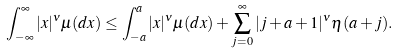<formula> <loc_0><loc_0><loc_500><loc_500>\int _ { - \infty } ^ { \infty } | x | ^ { \nu } \mu ( d x ) \leq \int _ { - a } ^ { a } | x | ^ { \nu } \mu ( d x ) + \sum _ { j = 0 } ^ { \infty } | j + a + 1 | ^ { \nu } \eta ( a + j ) .</formula> 